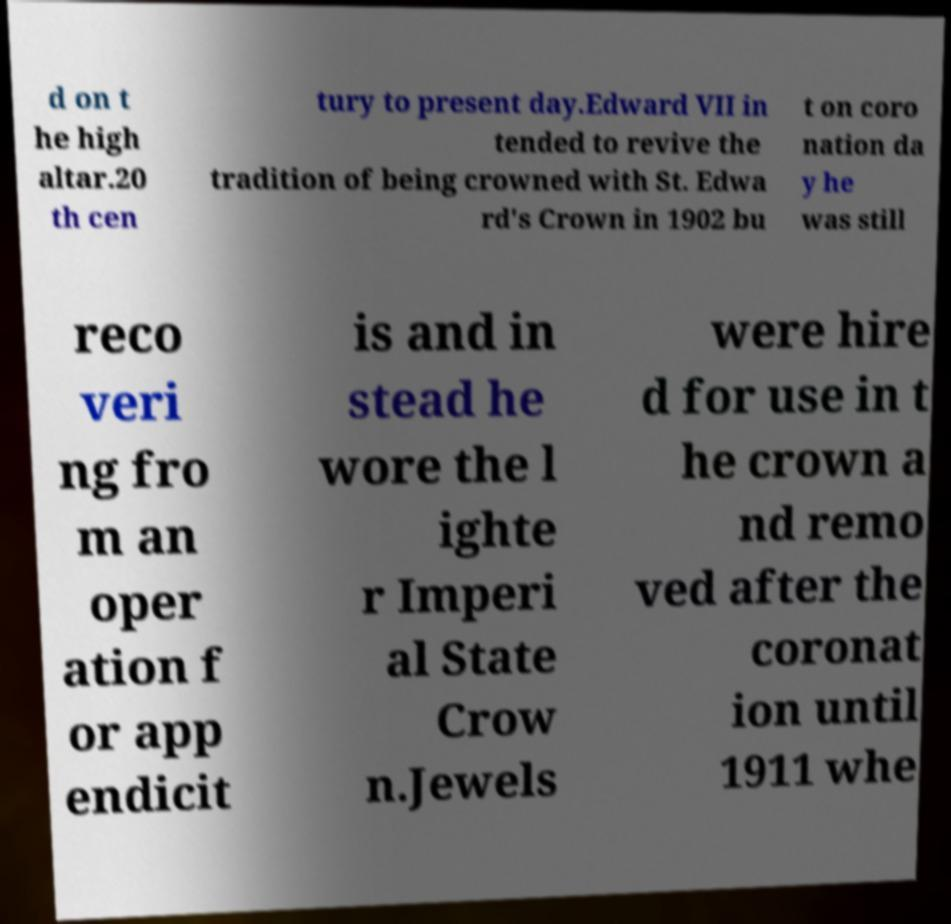Please identify and transcribe the text found in this image. d on t he high altar.20 th cen tury to present day.Edward VII in tended to revive the tradition of being crowned with St. Edwa rd's Crown in 1902 bu t on coro nation da y he was still reco veri ng fro m an oper ation f or app endicit is and in stead he wore the l ighte r Imperi al State Crow n.Jewels were hire d for use in t he crown a nd remo ved after the coronat ion until 1911 whe 